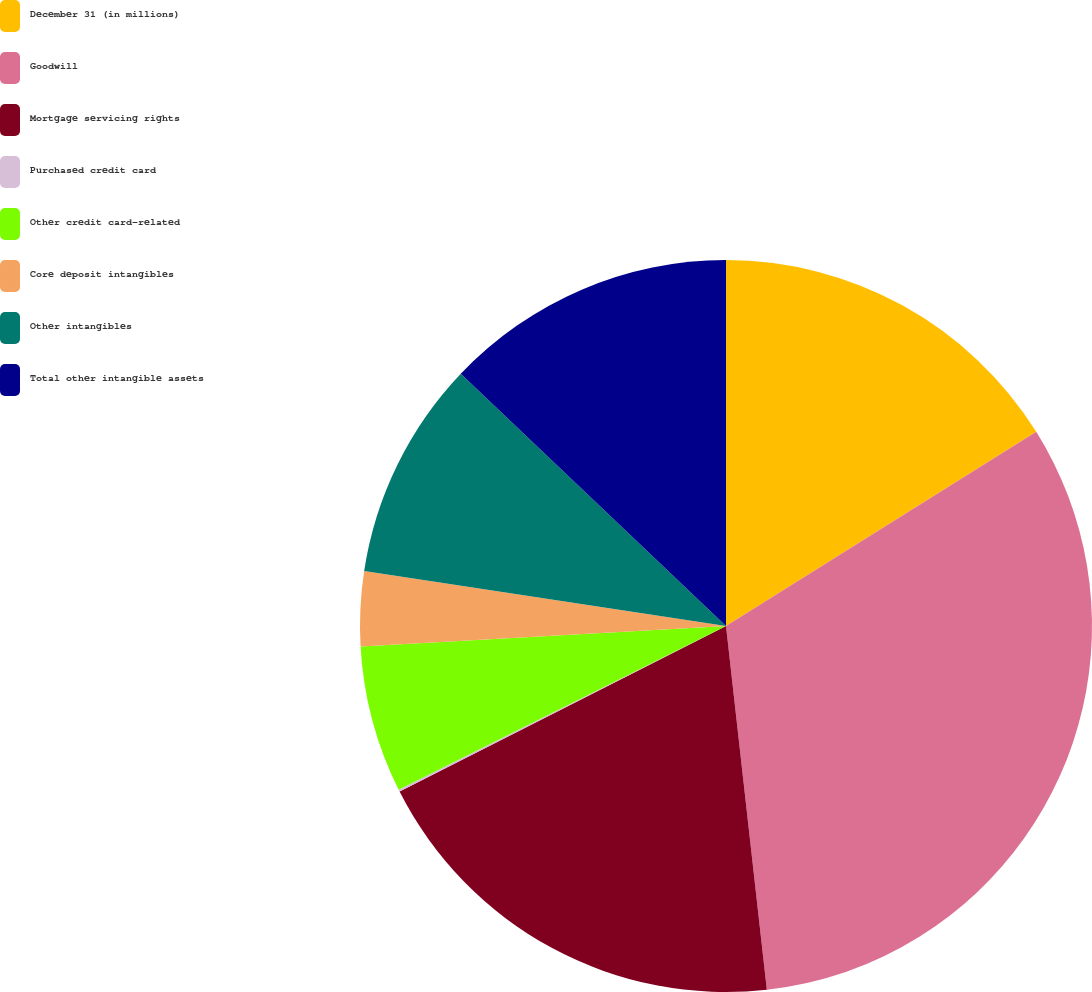<chart> <loc_0><loc_0><loc_500><loc_500><pie_chart><fcel>December 31 (in millions)<fcel>Goodwill<fcel>Mortgage servicing rights<fcel>Purchased credit card<fcel>Other credit card-related<fcel>Core deposit intangibles<fcel>Other intangibles<fcel>Total other intangible assets<nl><fcel>16.1%<fcel>32.12%<fcel>19.31%<fcel>0.09%<fcel>6.49%<fcel>3.29%<fcel>9.7%<fcel>12.9%<nl></chart> 